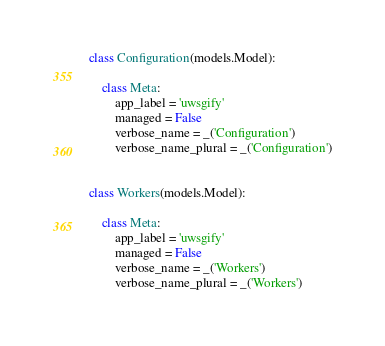Convert code to text. <code><loc_0><loc_0><loc_500><loc_500><_Python_>

class Configuration(models.Model):

    class Meta:
        app_label = 'uwsgify'
        managed = False
        verbose_name = _('Configuration')
        verbose_name_plural = _('Configuration')


class Workers(models.Model):

    class Meta:
        app_label = 'uwsgify'
        managed = False
        verbose_name = _('Workers')
        verbose_name_plural = _('Workers')
</code> 